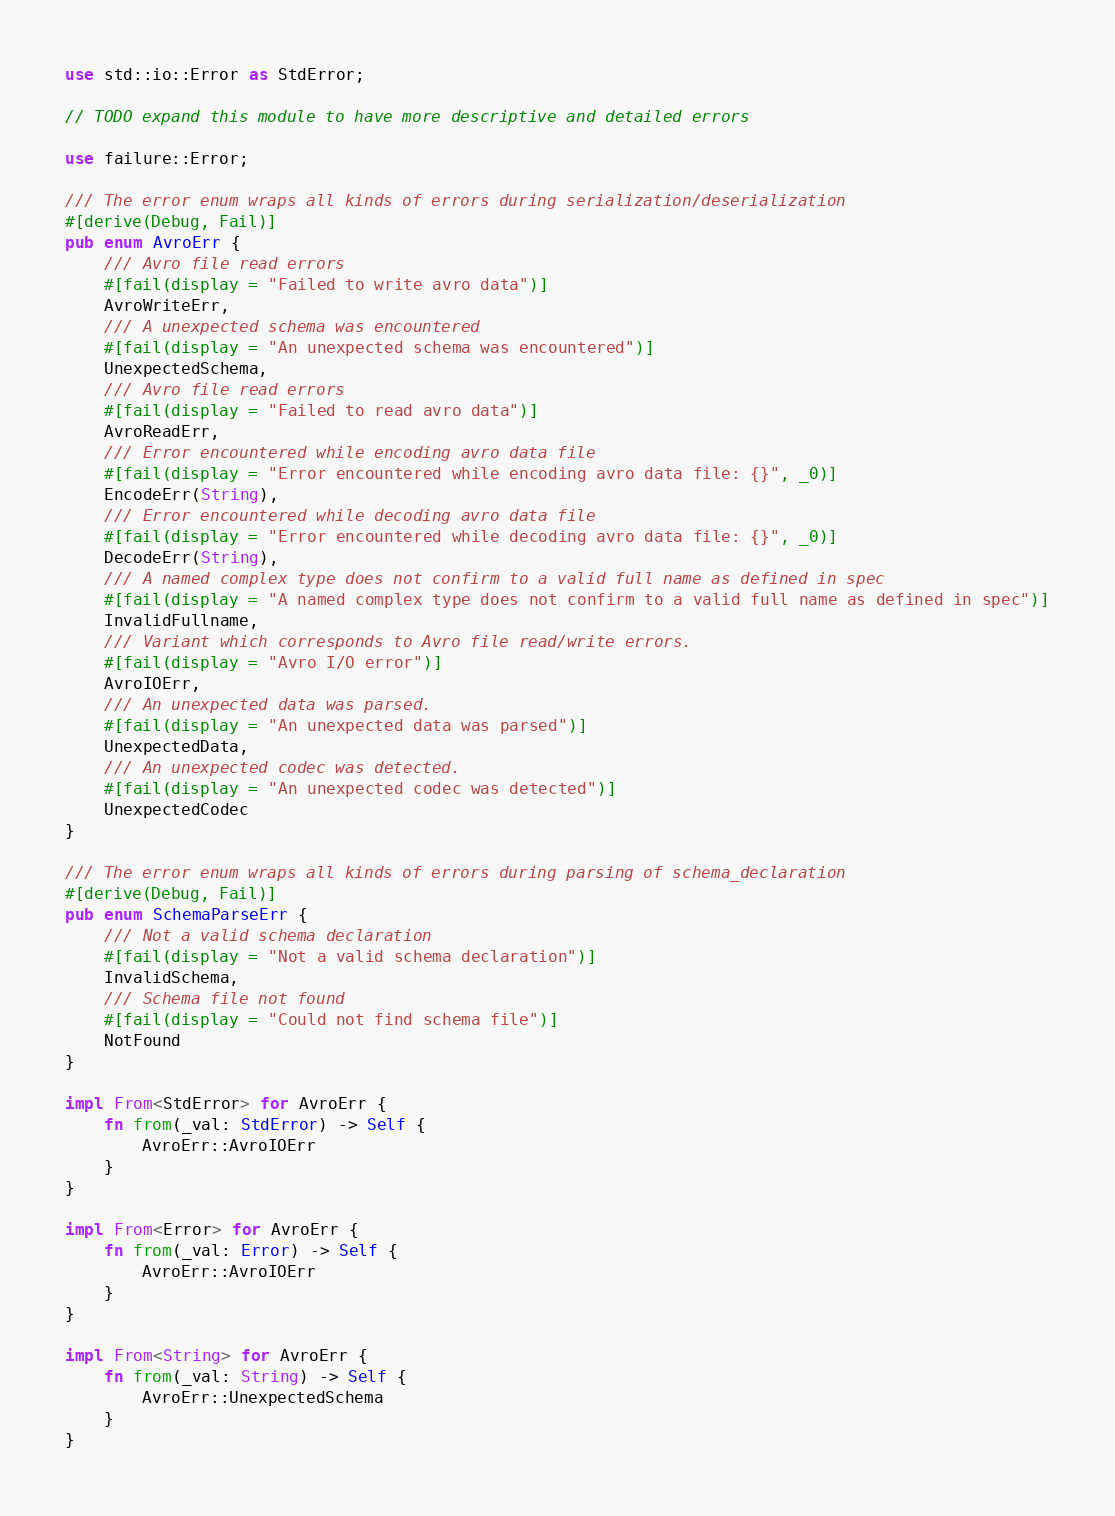<code> <loc_0><loc_0><loc_500><loc_500><_Rust_>
use std::io::Error as StdError;

// TODO expand this module to have more descriptive and detailed errors

use failure::Error;

/// The error enum wraps all kinds of errors during serialization/deserialization
#[derive(Debug, Fail)]
pub enum AvroErr {
    /// Avro file read errors
    #[fail(display = "Failed to write avro data")]
    AvroWriteErr,
    /// A unexpected schema was encountered
    #[fail(display = "An unexpected schema was encountered")]
    UnexpectedSchema,
    /// Avro file read errors
    #[fail(display = "Failed to read avro data")]
    AvroReadErr,
    /// Error encountered while encoding avro data file
    #[fail(display = "Error encountered while encoding avro data file: {}", _0)]
    EncodeErr(String),
    /// Error encountered while decoding avro data file
    #[fail(display = "Error encountered while decoding avro data file: {}", _0)]
    DecodeErr(String),
    /// A named complex type does not confirm to a valid full name as defined in spec
    #[fail(display = "A named complex type does not confirm to a valid full name as defined in spec")]
    InvalidFullname,
    /// Variant which corresponds to Avro file read/write errors.
    #[fail(display = "Avro I/O error")]
    AvroIOErr,
    /// An unexpected data was parsed.
    #[fail(display = "An unexpected data was parsed")]
    UnexpectedData,
    /// An unexpected codec was detected.
    #[fail(display = "An unexpected codec was detected")]
    UnexpectedCodec
}

/// The error enum wraps all kinds of errors during parsing of schema_declaration
#[derive(Debug, Fail)]
pub enum SchemaParseErr {
    /// Not a valid schema declaration
    #[fail(display = "Not a valid schema declaration")]
    InvalidSchema,
    /// Schema file not found
    #[fail(display = "Could not find schema file")]
    NotFound
}

impl From<StdError> for AvroErr {
    fn from(_val: StdError) -> Self {
        AvroErr::AvroIOErr
    }
}

impl From<Error> for AvroErr {
    fn from(_val: Error) -> Self {
        AvroErr::AvroIOErr
    }
}

impl From<String> for AvroErr {
    fn from(_val: String) -> Self {
        AvroErr::UnexpectedSchema
    }
}
</code> 